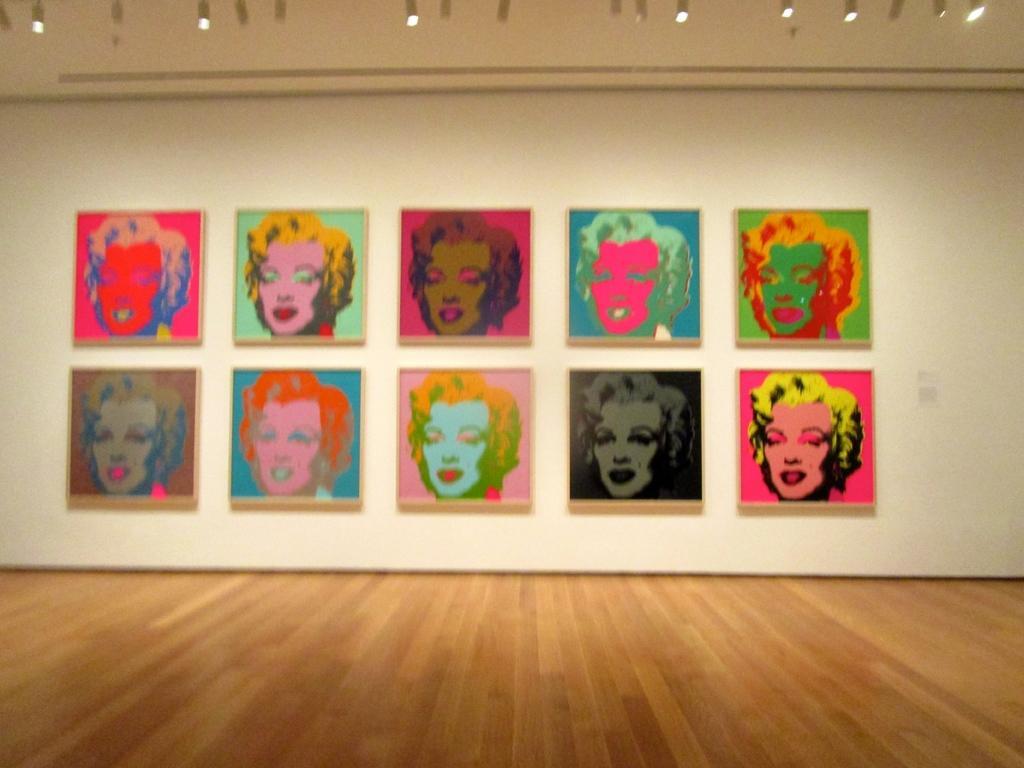Can you describe this image briefly? In this picture, we can see an inner view of a room, we can see the ground, wall with posters, and the roof with lights. 